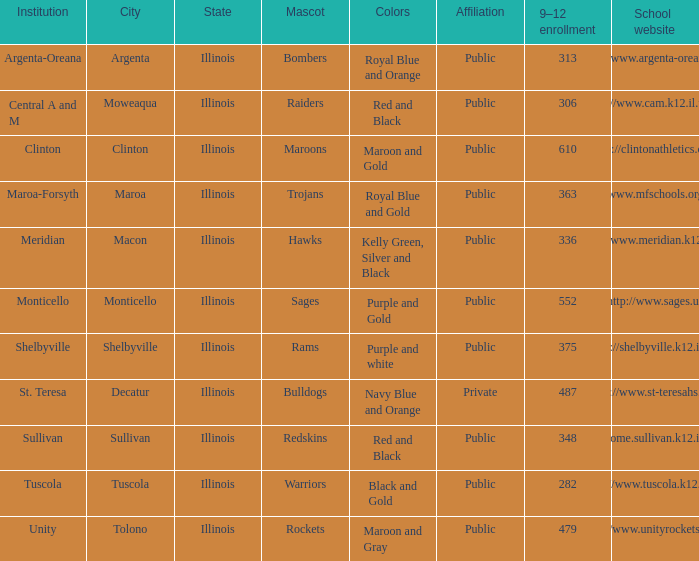What's the website of the school in Macon, Illinois? Http://www.meridian.k12.il.us/. 